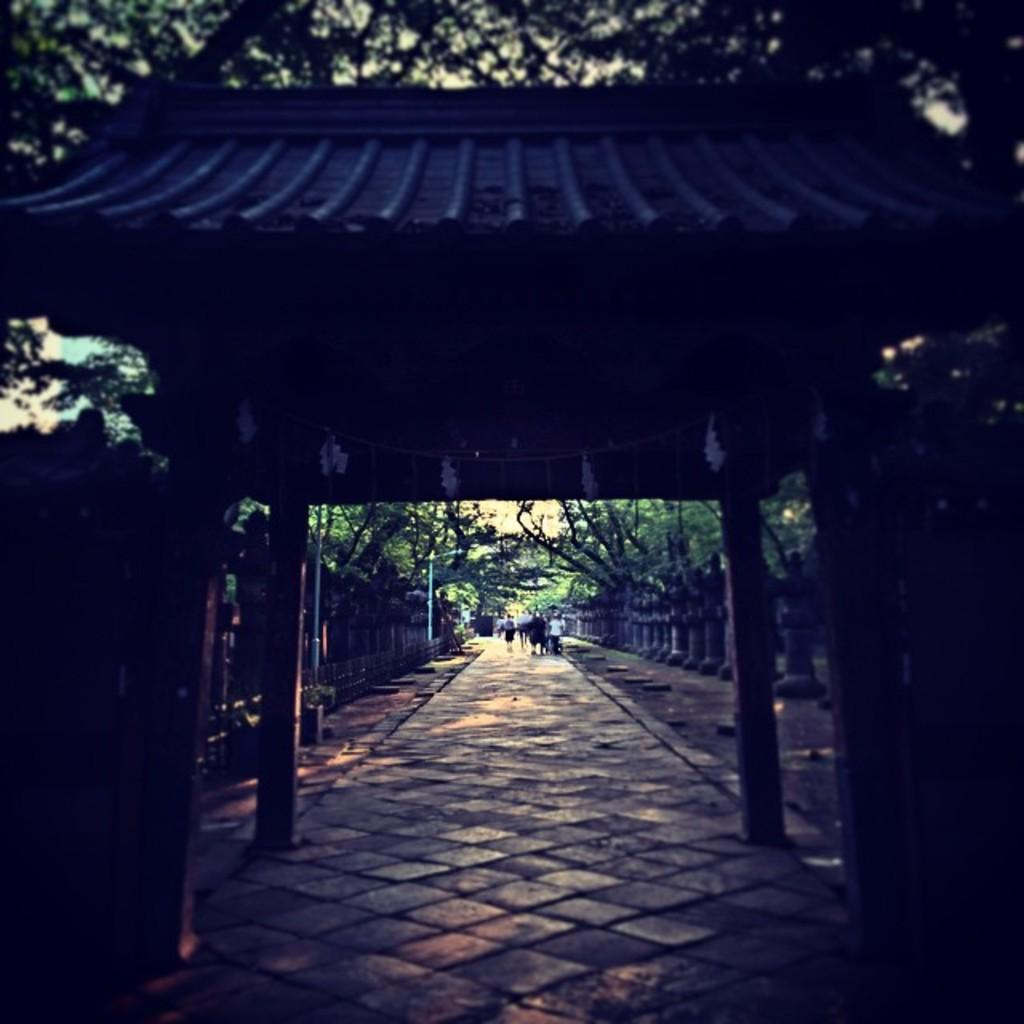What type of structure is present in the image? There is an arch in the image. What can be seen in the background of the image? There are trees, pillars, a group of people walking, and the sky visible in the background of the image. What type of brass instrument is being played by the group of people walking in the image? There is no brass instrument or any indication of musical activity in the image. 